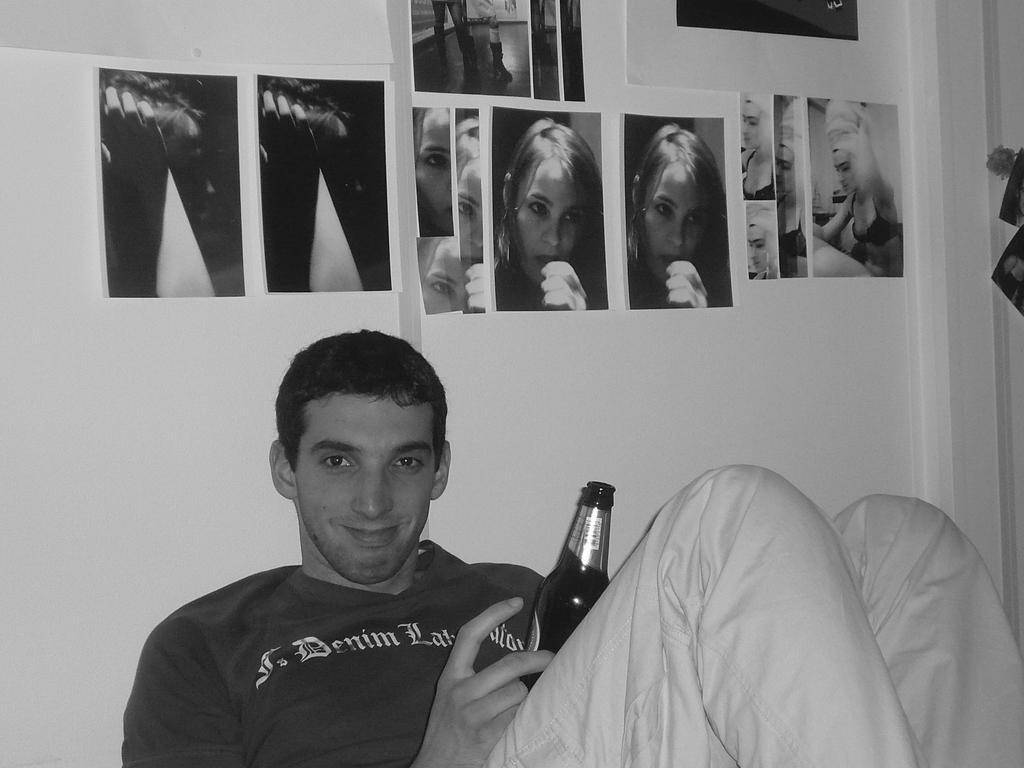Please provide a concise description of this image. He is a man who is laying on something he is taking support of his background he is holding a bottle in his right hand , he is wearing a black color shirt and he is smiling ,in the background we can see few photographs that are stick to the wall. 